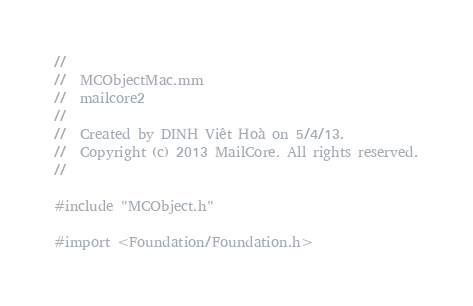<code> <loc_0><loc_0><loc_500><loc_500><_ObjectiveC_>//
//  MCObjectMac.mm
//  mailcore2
//
//  Created by DINH Viêt Hoà on 5/4/13.
//  Copyright (c) 2013 MailCore. All rights reserved.
//

#include "MCObject.h"

#import <Foundation/Foundation.h>
</code> 